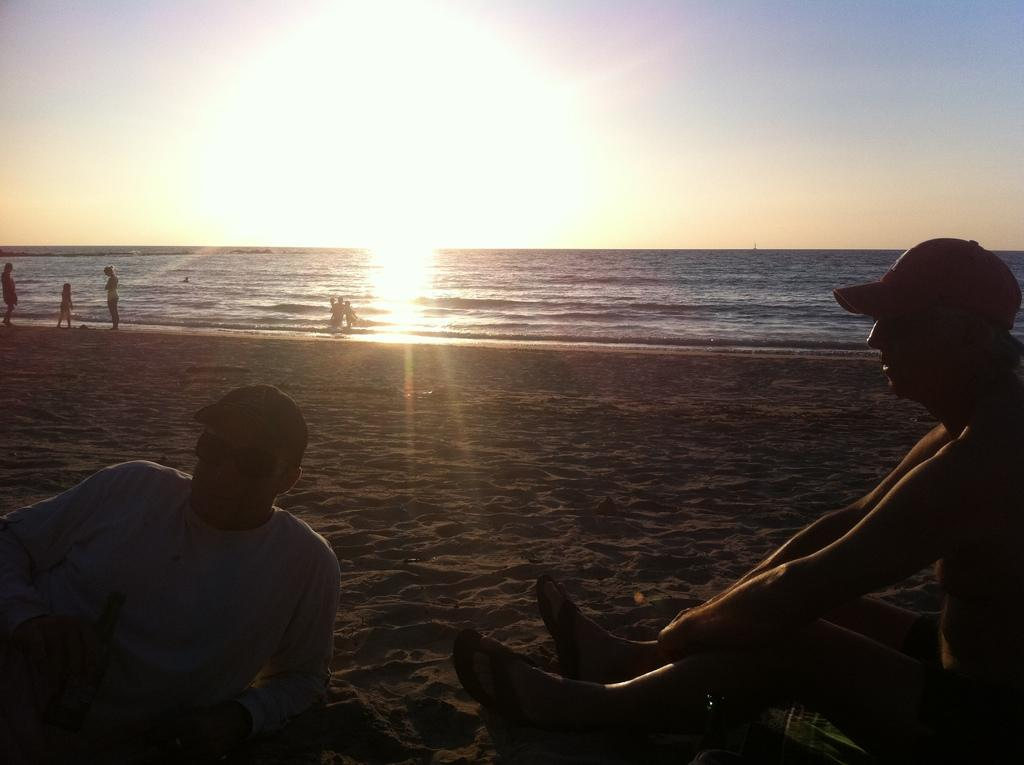What is the person in the image holding? A: The person is holding an umbrella in the image. What is the person doing with the umbrella? The person is holding the umbrella in the rain. What is the weather like in the image? It is raining in the image. What is the person wearing while holding the umbrella? The facts provided do not mention what the person is wearing. What type of meat is being cooked on the grill in the image? There is no grill or meat present in the image; it features a person holding an umbrella in the rain. 